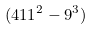<formula> <loc_0><loc_0><loc_500><loc_500>( 4 1 1 ^ { 2 } - 9 ^ { 3 } )</formula> 